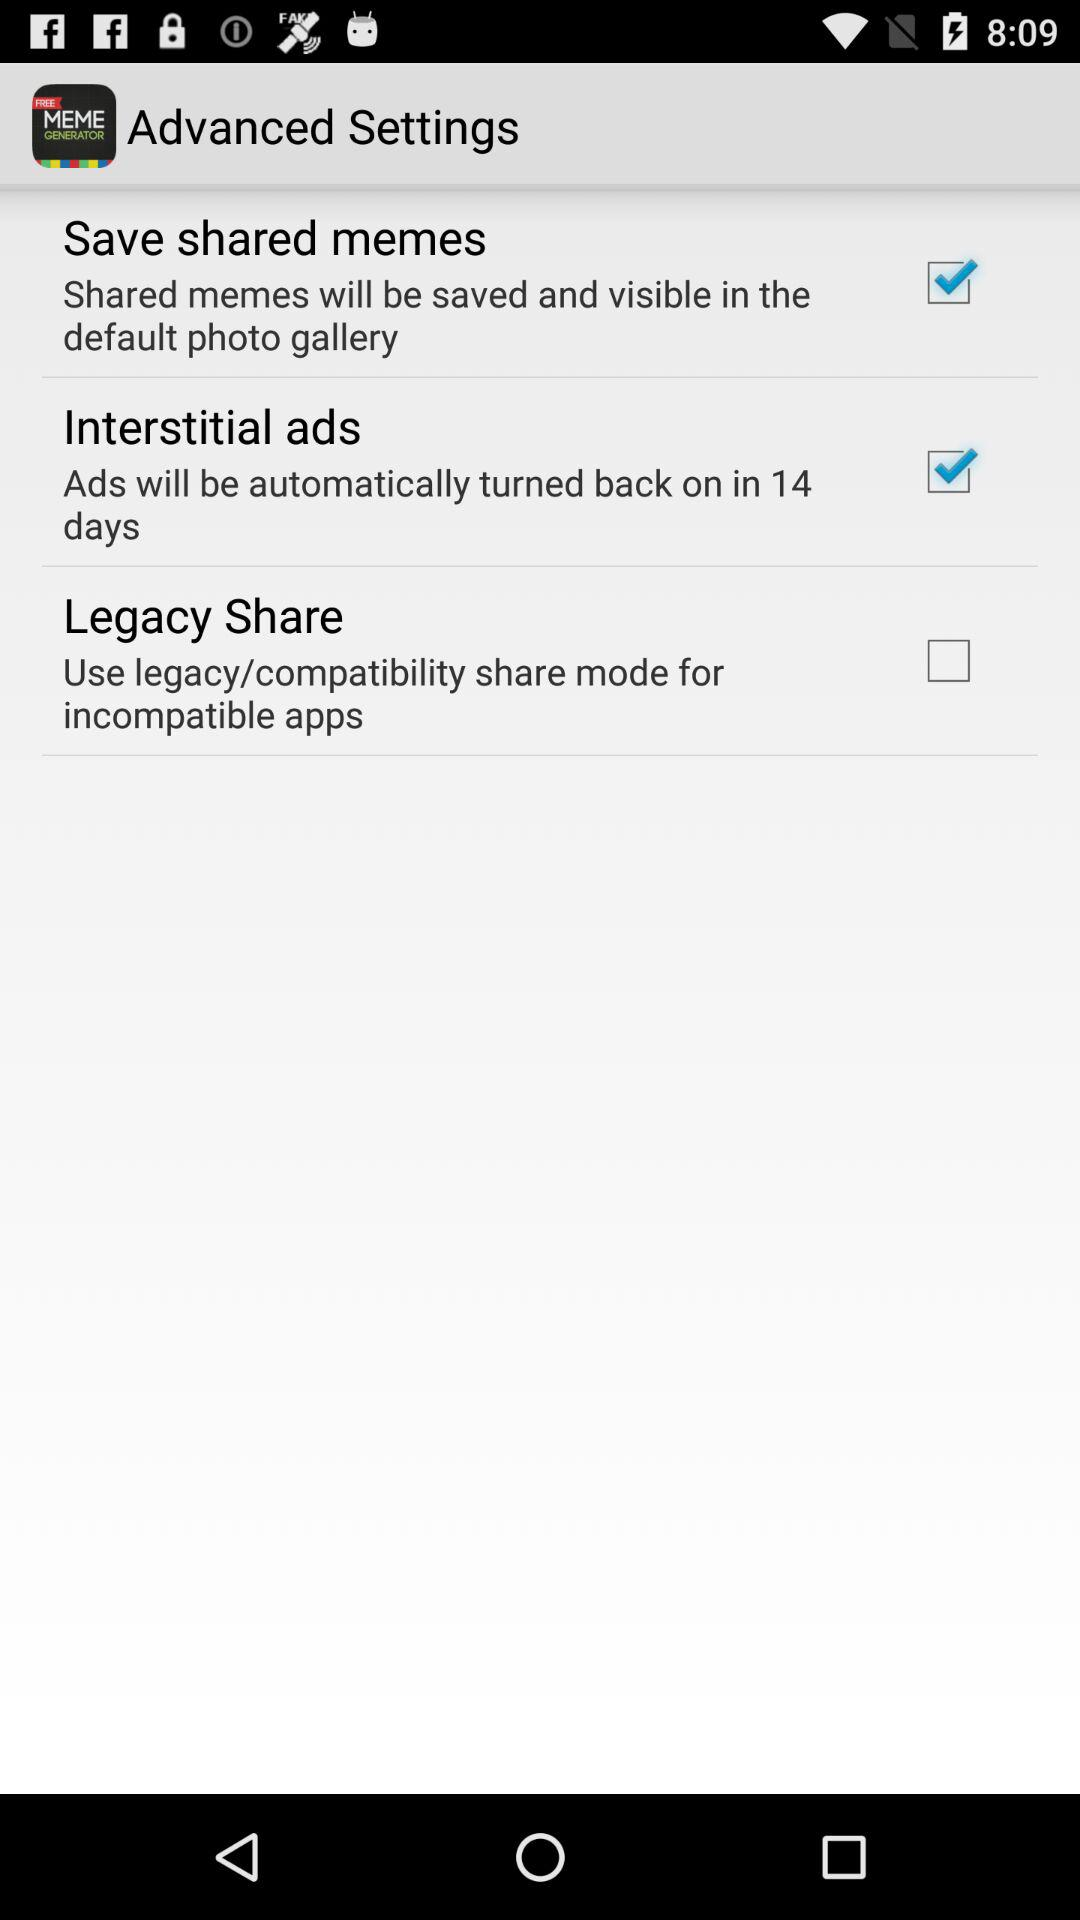Which option should we select to use legacy share mode? You should select the "Legacy Share" option to use legacy share mode. 